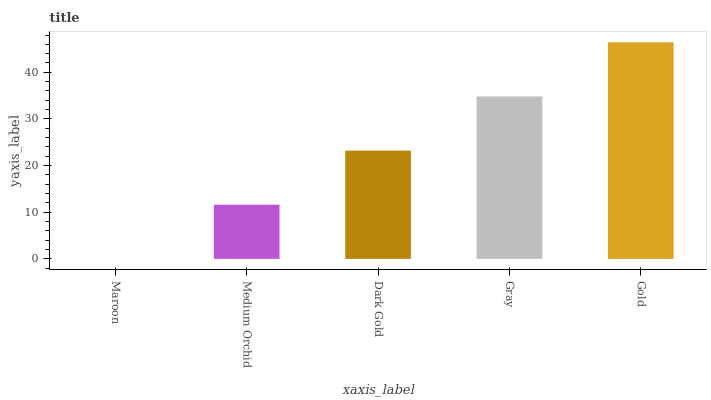Is Maroon the minimum?
Answer yes or no. Yes. Is Gold the maximum?
Answer yes or no. Yes. Is Medium Orchid the minimum?
Answer yes or no. No. Is Medium Orchid the maximum?
Answer yes or no. No. Is Medium Orchid greater than Maroon?
Answer yes or no. Yes. Is Maroon less than Medium Orchid?
Answer yes or no. Yes. Is Maroon greater than Medium Orchid?
Answer yes or no. No. Is Medium Orchid less than Maroon?
Answer yes or no. No. Is Dark Gold the high median?
Answer yes or no. Yes. Is Dark Gold the low median?
Answer yes or no. Yes. Is Gold the high median?
Answer yes or no. No. Is Maroon the low median?
Answer yes or no. No. 